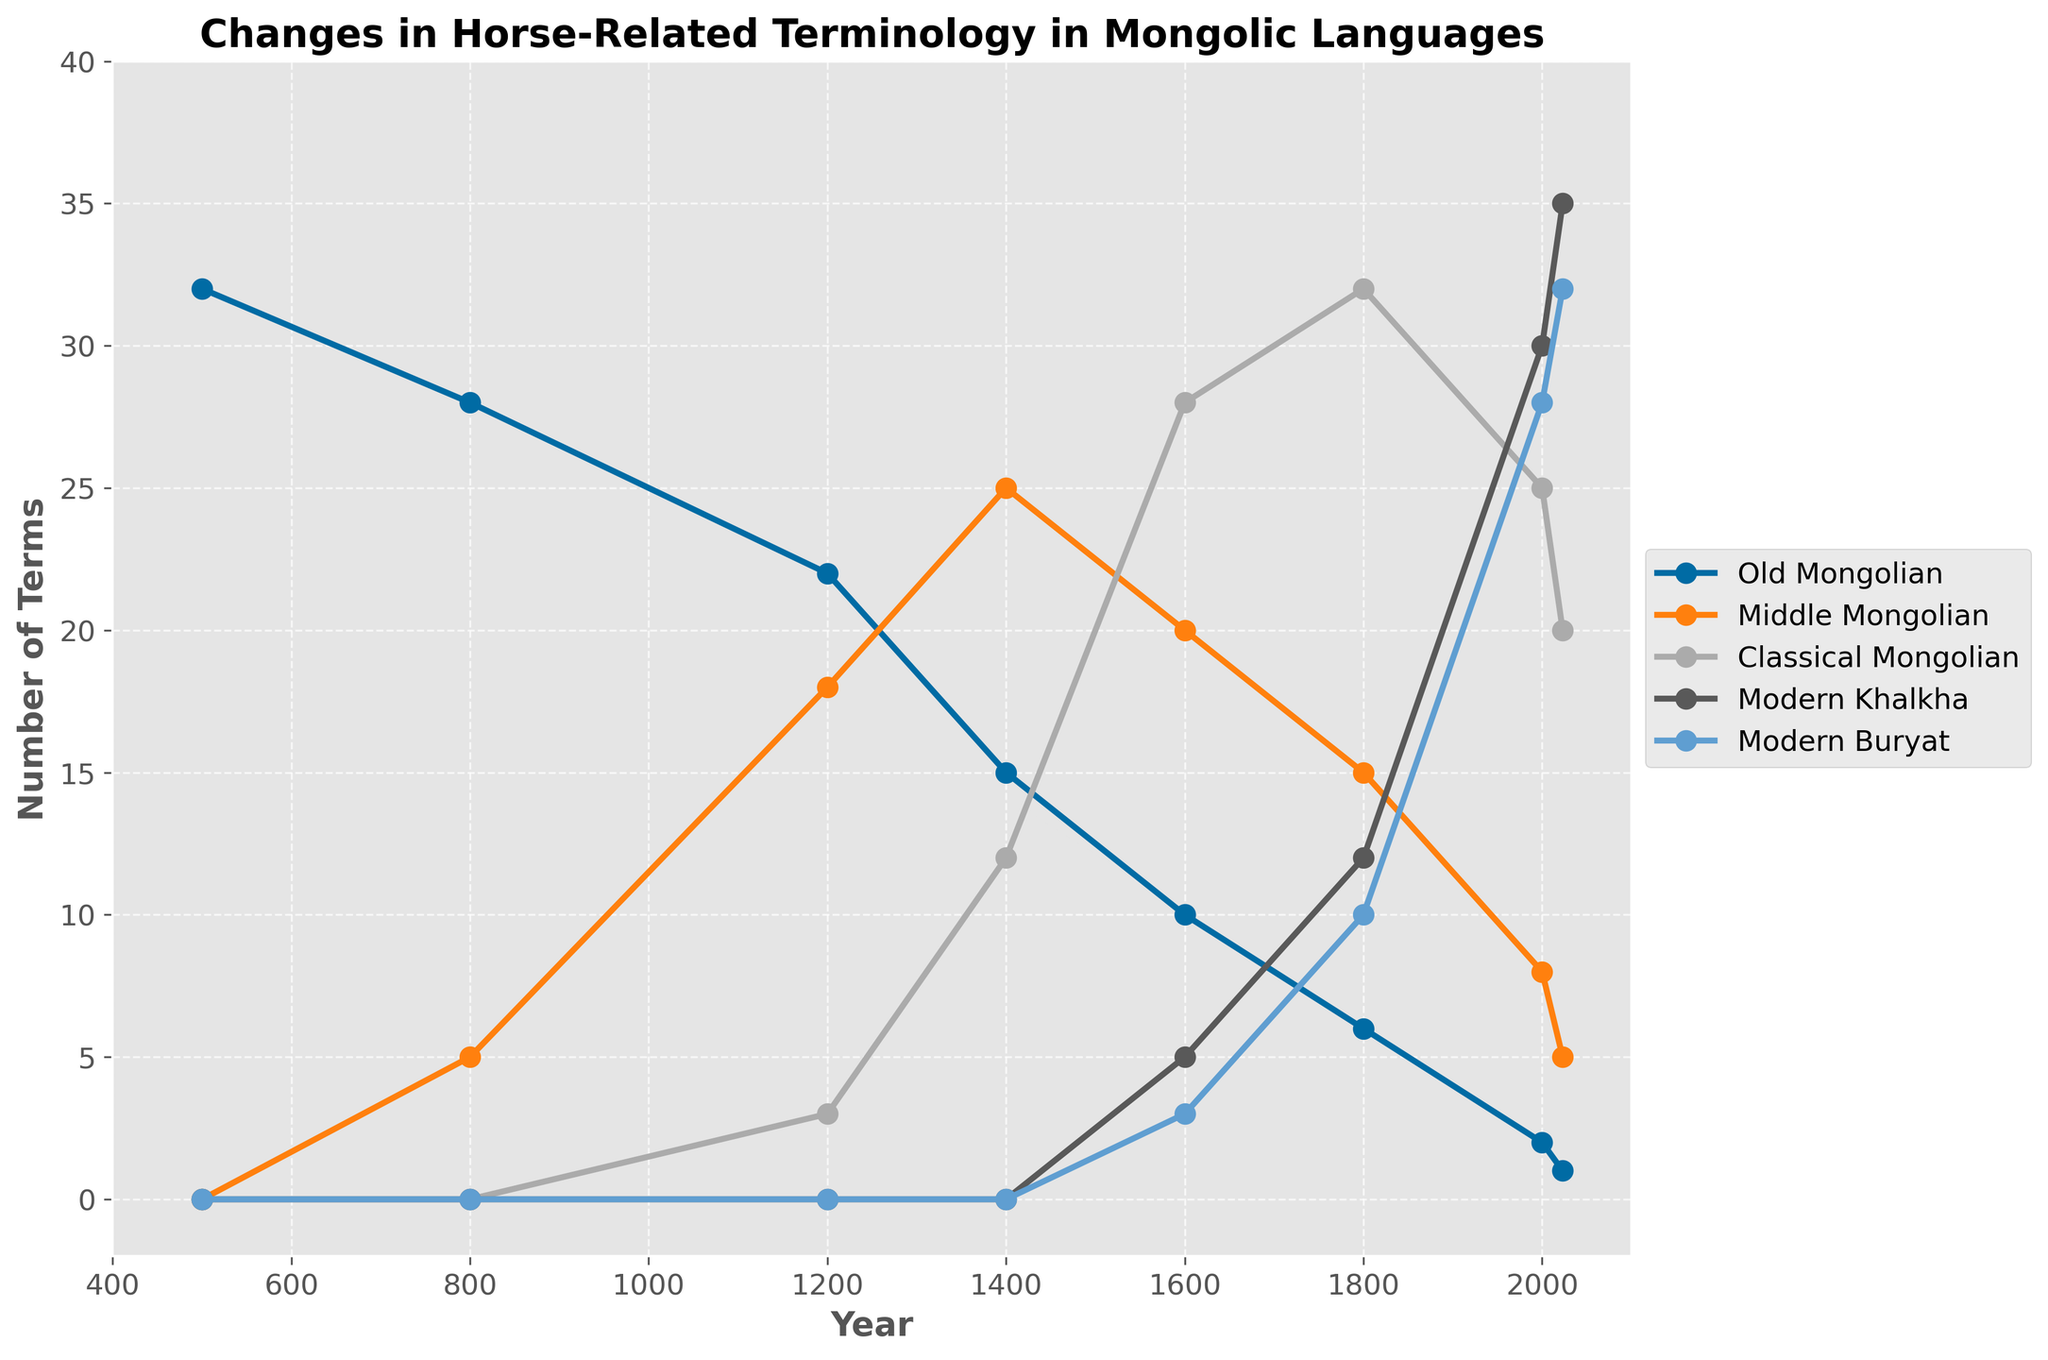Which Mongolic language showed the most significant decrease in horse-related terminology from the year 500 to 2023? Comparing the data points for each language, Old Mongolian decreased from 32 terms in the year 500 to 1 term in 2023. The decrease (32 - 1) is 31 terms, which is the largest decrease among all languages.
Answer: Old Mongolian Around which year did Modern Khalkha surpass Classical Mongolian in the number of horse-related terms? By examining the graph, Modern Khalkha first surpasses Classical Mongolian around the year 2000, where Modern Khalkha has around 30 terms and Classical Mongolian has around 25 terms.
Answer: 2000 How did the number of horse-related terms in Middle Mongolian change between 1200 and 1800? From 1200 to 1800, Middle Mongolian decreased from 18 terms to 15 terms in 1400, increased to 20 terms in 1600, and further decreased to 15 terms in 1800, showing fluctuation.
Answer: Fluctuated, then no change Which language had the highest number of horse-related terms in the year 1400? Referring to the data points for 1400, Middle Mongolian had the highest number of terms, with 25 terms compared to 15 in Old Mongolian and 12 in Classical Mongolian.
Answer: Middle Mongolian In which years did Old Mongolian have more terms than Modern Khalkha and Modern Buryat combined? Old Mongolian terms were greater than the combined terms of Modern Khalkha and Modern Buryat in the years 500, 800, 1200, 1400, and 1600.
Answer: 500, 800, 1200, 1400, 1600 How many terms are there in Classical Mongolian and Modern Khalkha combined in 2023? The number of terms in Classical Mongolian in 2023 is 20, and in Modern Khalkha is 35. Added together, the combined number is 20 + 35 = 55.
Answer: 55 Compare the trend of terminology changes for Modern Buryat between 1600 and 2023 to Classical Mongolian between 1800 and 2023. Modern Buryat increases steadily from 3 terms in 1600 to 32 terms in 2023. Classical Mongolian decreases from 32 terms in 1800 to 20 terms in 2023. The trends are opposite; one increases while the other decreases.
Answer: Opposite trends During which centuries did Old Mongolian and Middle Mongolian have convergent trends in terms of horse-related terminology? Between 1200 and 1400, both Old Mongolian and Middle Mongolian decrease in the number of terms, with Old Mongolian dropping from 22 to 15 and Middle Mongolian increasing from 18 to 25.
Answer: 12th to 14th centuries 